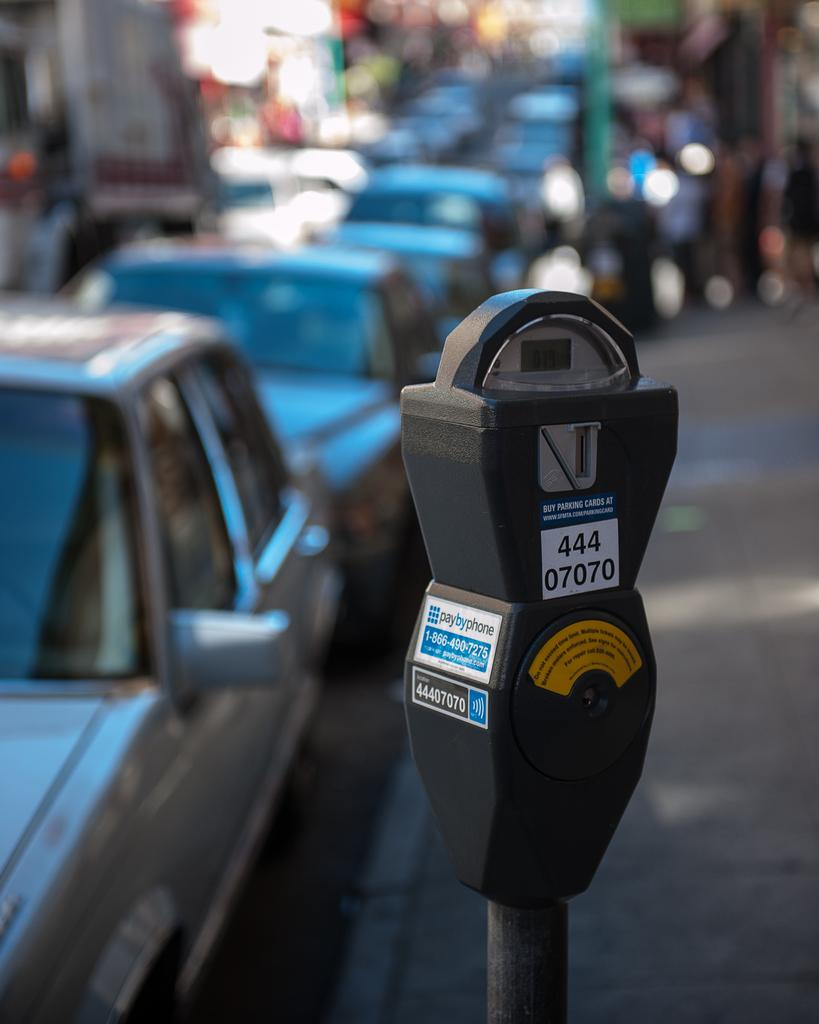<image>
Write a terse but informative summary of the picture. A parking meter has the numbers 44407070 on the front. 